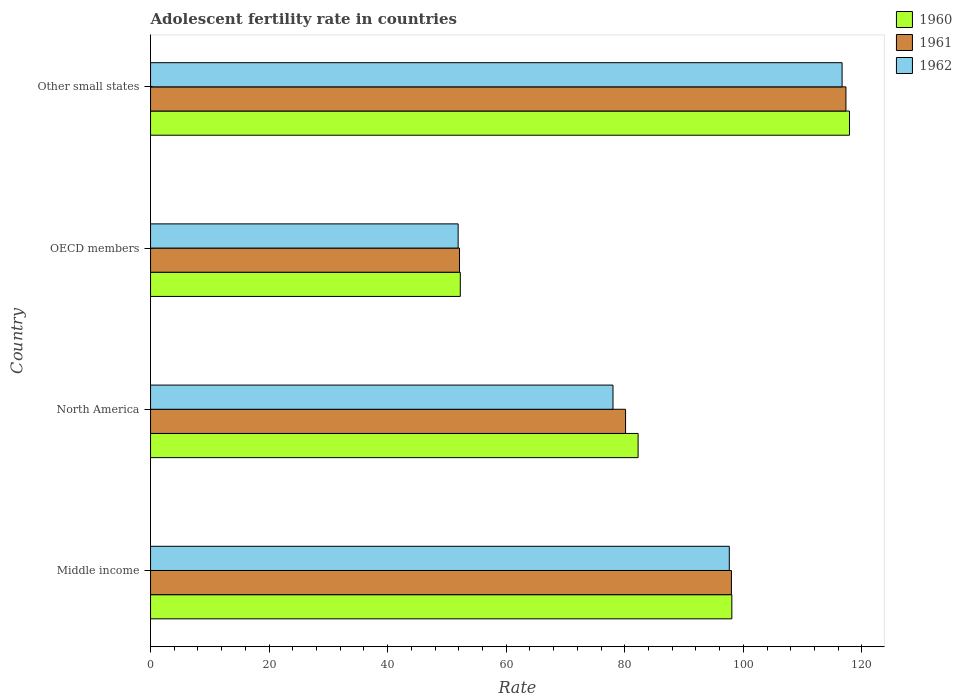How many groups of bars are there?
Your answer should be compact. 4. Are the number of bars on each tick of the Y-axis equal?
Offer a very short reply. Yes. How many bars are there on the 2nd tick from the top?
Give a very brief answer. 3. What is the adolescent fertility rate in 1962 in Middle income?
Your response must be concise. 97.62. Across all countries, what is the maximum adolescent fertility rate in 1962?
Your answer should be very brief. 116.65. Across all countries, what is the minimum adolescent fertility rate in 1962?
Provide a succinct answer. 51.88. In which country was the adolescent fertility rate in 1960 maximum?
Provide a succinct answer. Other small states. In which country was the adolescent fertility rate in 1962 minimum?
Your response must be concise. OECD members. What is the total adolescent fertility rate in 1960 in the graph?
Make the answer very short. 350.43. What is the difference between the adolescent fertility rate in 1960 in North America and that in Other small states?
Your response must be concise. -35.65. What is the difference between the adolescent fertility rate in 1960 in Middle income and the adolescent fertility rate in 1962 in OECD members?
Offer a very short reply. 46.17. What is the average adolescent fertility rate in 1960 per country?
Keep it short and to the point. 87.61. What is the difference between the adolescent fertility rate in 1961 and adolescent fertility rate in 1960 in Other small states?
Offer a very short reply. -0.6. What is the ratio of the adolescent fertility rate in 1960 in Middle income to that in Other small states?
Keep it short and to the point. 0.83. Is the difference between the adolescent fertility rate in 1961 in North America and OECD members greater than the difference between the adolescent fertility rate in 1960 in North America and OECD members?
Provide a short and direct response. No. What is the difference between the highest and the second highest adolescent fertility rate in 1961?
Make the answer very short. 19.31. What is the difference between the highest and the lowest adolescent fertility rate in 1960?
Provide a short and direct response. 65.65. Is the sum of the adolescent fertility rate in 1960 in Middle income and North America greater than the maximum adolescent fertility rate in 1962 across all countries?
Your response must be concise. Yes. Is it the case that in every country, the sum of the adolescent fertility rate in 1961 and adolescent fertility rate in 1960 is greater than the adolescent fertility rate in 1962?
Your answer should be very brief. Yes. Are all the bars in the graph horizontal?
Ensure brevity in your answer.  Yes. What is the difference between two consecutive major ticks on the X-axis?
Make the answer very short. 20. Does the graph contain any zero values?
Offer a very short reply. No. Where does the legend appear in the graph?
Offer a very short reply. Top right. How many legend labels are there?
Keep it short and to the point. 3. How are the legend labels stacked?
Ensure brevity in your answer.  Vertical. What is the title of the graph?
Offer a terse response. Adolescent fertility rate in countries. What is the label or title of the X-axis?
Keep it short and to the point. Rate. What is the Rate of 1960 in Middle income?
Ensure brevity in your answer.  98.05. What is the Rate of 1961 in Middle income?
Keep it short and to the point. 97.98. What is the Rate in 1962 in Middle income?
Provide a short and direct response. 97.62. What is the Rate of 1960 in North America?
Provide a succinct answer. 82.24. What is the Rate of 1961 in North America?
Offer a very short reply. 80.12. What is the Rate of 1962 in North America?
Offer a very short reply. 78. What is the Rate in 1960 in OECD members?
Your response must be concise. 52.25. What is the Rate of 1961 in OECD members?
Ensure brevity in your answer.  52.11. What is the Rate of 1962 in OECD members?
Provide a succinct answer. 51.88. What is the Rate of 1960 in Other small states?
Offer a very short reply. 117.89. What is the Rate of 1961 in Other small states?
Make the answer very short. 117.3. What is the Rate in 1962 in Other small states?
Your answer should be compact. 116.65. Across all countries, what is the maximum Rate in 1960?
Give a very brief answer. 117.89. Across all countries, what is the maximum Rate of 1961?
Ensure brevity in your answer.  117.3. Across all countries, what is the maximum Rate in 1962?
Make the answer very short. 116.65. Across all countries, what is the minimum Rate of 1960?
Offer a terse response. 52.25. Across all countries, what is the minimum Rate in 1961?
Your answer should be compact. 52.11. Across all countries, what is the minimum Rate of 1962?
Ensure brevity in your answer.  51.88. What is the total Rate of 1960 in the graph?
Make the answer very short. 350.43. What is the total Rate in 1961 in the graph?
Your answer should be compact. 347.52. What is the total Rate of 1962 in the graph?
Keep it short and to the point. 344.16. What is the difference between the Rate of 1960 in Middle income and that in North America?
Provide a succinct answer. 15.81. What is the difference between the Rate of 1961 in Middle income and that in North America?
Give a very brief answer. 17.86. What is the difference between the Rate in 1962 in Middle income and that in North America?
Your answer should be very brief. 19.62. What is the difference between the Rate in 1960 in Middle income and that in OECD members?
Provide a succinct answer. 45.81. What is the difference between the Rate in 1961 in Middle income and that in OECD members?
Your response must be concise. 45.87. What is the difference between the Rate of 1962 in Middle income and that in OECD members?
Your answer should be compact. 45.74. What is the difference between the Rate in 1960 in Middle income and that in Other small states?
Give a very brief answer. -19.84. What is the difference between the Rate in 1961 in Middle income and that in Other small states?
Offer a terse response. -19.31. What is the difference between the Rate of 1962 in Middle income and that in Other small states?
Keep it short and to the point. -19.02. What is the difference between the Rate of 1960 in North America and that in OECD members?
Your answer should be compact. 29.99. What is the difference between the Rate of 1961 in North America and that in OECD members?
Your answer should be very brief. 28.01. What is the difference between the Rate of 1962 in North America and that in OECD members?
Your response must be concise. 26.12. What is the difference between the Rate of 1960 in North America and that in Other small states?
Offer a terse response. -35.65. What is the difference between the Rate in 1961 in North America and that in Other small states?
Provide a succinct answer. -37.17. What is the difference between the Rate of 1962 in North America and that in Other small states?
Make the answer very short. -38.64. What is the difference between the Rate of 1960 in OECD members and that in Other small states?
Your response must be concise. -65.65. What is the difference between the Rate of 1961 in OECD members and that in Other small states?
Give a very brief answer. -65.18. What is the difference between the Rate of 1962 in OECD members and that in Other small states?
Your response must be concise. -64.76. What is the difference between the Rate of 1960 in Middle income and the Rate of 1961 in North America?
Keep it short and to the point. 17.93. What is the difference between the Rate of 1960 in Middle income and the Rate of 1962 in North America?
Offer a very short reply. 20.05. What is the difference between the Rate of 1961 in Middle income and the Rate of 1962 in North America?
Ensure brevity in your answer.  19.98. What is the difference between the Rate in 1960 in Middle income and the Rate in 1961 in OECD members?
Make the answer very short. 45.94. What is the difference between the Rate of 1960 in Middle income and the Rate of 1962 in OECD members?
Make the answer very short. 46.17. What is the difference between the Rate of 1961 in Middle income and the Rate of 1962 in OECD members?
Offer a very short reply. 46.1. What is the difference between the Rate in 1960 in Middle income and the Rate in 1961 in Other small states?
Your response must be concise. -19.24. What is the difference between the Rate in 1960 in Middle income and the Rate in 1962 in Other small states?
Your answer should be very brief. -18.59. What is the difference between the Rate of 1961 in Middle income and the Rate of 1962 in Other small states?
Make the answer very short. -18.66. What is the difference between the Rate of 1960 in North America and the Rate of 1961 in OECD members?
Make the answer very short. 30.13. What is the difference between the Rate of 1960 in North America and the Rate of 1962 in OECD members?
Ensure brevity in your answer.  30.36. What is the difference between the Rate in 1961 in North America and the Rate in 1962 in OECD members?
Ensure brevity in your answer.  28.24. What is the difference between the Rate of 1960 in North America and the Rate of 1961 in Other small states?
Provide a short and direct response. -35.06. What is the difference between the Rate in 1960 in North America and the Rate in 1962 in Other small states?
Keep it short and to the point. -34.41. What is the difference between the Rate in 1961 in North America and the Rate in 1962 in Other small states?
Give a very brief answer. -36.52. What is the difference between the Rate in 1960 in OECD members and the Rate in 1961 in Other small states?
Give a very brief answer. -65.05. What is the difference between the Rate in 1960 in OECD members and the Rate in 1962 in Other small states?
Provide a short and direct response. -64.4. What is the difference between the Rate in 1961 in OECD members and the Rate in 1962 in Other small states?
Give a very brief answer. -64.53. What is the average Rate of 1960 per country?
Provide a short and direct response. 87.61. What is the average Rate in 1961 per country?
Provide a succinct answer. 86.88. What is the average Rate of 1962 per country?
Your answer should be compact. 86.04. What is the difference between the Rate in 1960 and Rate in 1961 in Middle income?
Keep it short and to the point. 0.07. What is the difference between the Rate of 1960 and Rate of 1962 in Middle income?
Give a very brief answer. 0.43. What is the difference between the Rate of 1961 and Rate of 1962 in Middle income?
Give a very brief answer. 0.36. What is the difference between the Rate in 1960 and Rate in 1961 in North America?
Offer a very short reply. 2.12. What is the difference between the Rate in 1960 and Rate in 1962 in North America?
Ensure brevity in your answer.  4.24. What is the difference between the Rate in 1961 and Rate in 1962 in North America?
Make the answer very short. 2.12. What is the difference between the Rate of 1960 and Rate of 1961 in OECD members?
Make the answer very short. 0.13. What is the difference between the Rate in 1960 and Rate in 1962 in OECD members?
Make the answer very short. 0.36. What is the difference between the Rate in 1961 and Rate in 1962 in OECD members?
Your answer should be compact. 0.23. What is the difference between the Rate of 1960 and Rate of 1961 in Other small states?
Your response must be concise. 0.6. What is the difference between the Rate in 1960 and Rate in 1962 in Other small states?
Your response must be concise. 1.25. What is the difference between the Rate in 1961 and Rate in 1962 in Other small states?
Make the answer very short. 0.65. What is the ratio of the Rate in 1960 in Middle income to that in North America?
Give a very brief answer. 1.19. What is the ratio of the Rate of 1961 in Middle income to that in North America?
Provide a succinct answer. 1.22. What is the ratio of the Rate in 1962 in Middle income to that in North America?
Provide a short and direct response. 1.25. What is the ratio of the Rate in 1960 in Middle income to that in OECD members?
Provide a succinct answer. 1.88. What is the ratio of the Rate in 1961 in Middle income to that in OECD members?
Provide a succinct answer. 1.88. What is the ratio of the Rate in 1962 in Middle income to that in OECD members?
Keep it short and to the point. 1.88. What is the ratio of the Rate in 1960 in Middle income to that in Other small states?
Offer a very short reply. 0.83. What is the ratio of the Rate in 1961 in Middle income to that in Other small states?
Offer a terse response. 0.84. What is the ratio of the Rate in 1962 in Middle income to that in Other small states?
Keep it short and to the point. 0.84. What is the ratio of the Rate in 1960 in North America to that in OECD members?
Your answer should be compact. 1.57. What is the ratio of the Rate in 1961 in North America to that in OECD members?
Keep it short and to the point. 1.54. What is the ratio of the Rate in 1962 in North America to that in OECD members?
Provide a short and direct response. 1.5. What is the ratio of the Rate of 1960 in North America to that in Other small states?
Ensure brevity in your answer.  0.7. What is the ratio of the Rate of 1961 in North America to that in Other small states?
Keep it short and to the point. 0.68. What is the ratio of the Rate in 1962 in North America to that in Other small states?
Offer a terse response. 0.67. What is the ratio of the Rate of 1960 in OECD members to that in Other small states?
Your answer should be very brief. 0.44. What is the ratio of the Rate in 1961 in OECD members to that in Other small states?
Your answer should be compact. 0.44. What is the ratio of the Rate of 1962 in OECD members to that in Other small states?
Offer a very short reply. 0.44. What is the difference between the highest and the second highest Rate in 1960?
Offer a very short reply. 19.84. What is the difference between the highest and the second highest Rate of 1961?
Provide a succinct answer. 19.31. What is the difference between the highest and the second highest Rate of 1962?
Make the answer very short. 19.02. What is the difference between the highest and the lowest Rate in 1960?
Provide a short and direct response. 65.65. What is the difference between the highest and the lowest Rate of 1961?
Make the answer very short. 65.18. What is the difference between the highest and the lowest Rate in 1962?
Your answer should be very brief. 64.76. 